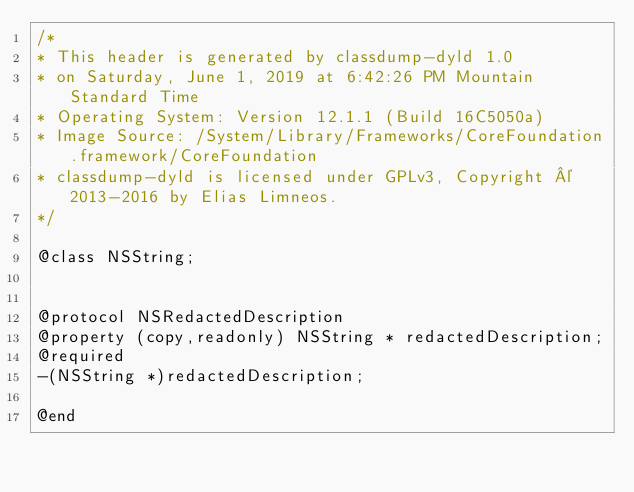Convert code to text. <code><loc_0><loc_0><loc_500><loc_500><_C_>/*
* This header is generated by classdump-dyld 1.0
* on Saturday, June 1, 2019 at 6:42:26 PM Mountain Standard Time
* Operating System: Version 12.1.1 (Build 16C5050a)
* Image Source: /System/Library/Frameworks/CoreFoundation.framework/CoreFoundation
* classdump-dyld is licensed under GPLv3, Copyright © 2013-2016 by Elias Limneos.
*/

@class NSString;


@protocol NSRedactedDescription
@property (copy,readonly) NSString * redactedDescription; 
@required
-(NSString *)redactedDescription;

@end

</code> 